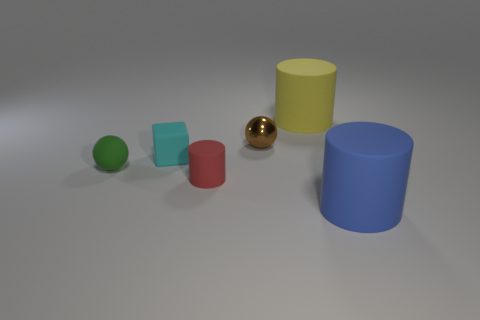Are there an equal number of green rubber things that are to the right of the matte block and small cyan blocks?
Your answer should be very brief. No. How many blue cylinders have the same material as the small red thing?
Your answer should be very brief. 1. There is another big cylinder that is the same material as the big blue cylinder; what color is it?
Give a very brief answer. Yellow. There is a matte block; is its size the same as the cylinder to the left of the yellow cylinder?
Your answer should be compact. Yes. The blue matte object has what shape?
Provide a succinct answer. Cylinder. The other large thing that is the same shape as the yellow matte thing is what color?
Give a very brief answer. Blue. How many tiny green objects are on the right side of the small sphere to the right of the tiny red rubber cylinder?
Keep it short and to the point. 0. What number of cylinders are large yellow matte objects or red metallic things?
Offer a terse response. 1. Are there any big red cylinders?
Provide a succinct answer. No. What is the size of the blue object that is the same shape as the yellow rubber object?
Give a very brief answer. Large. 